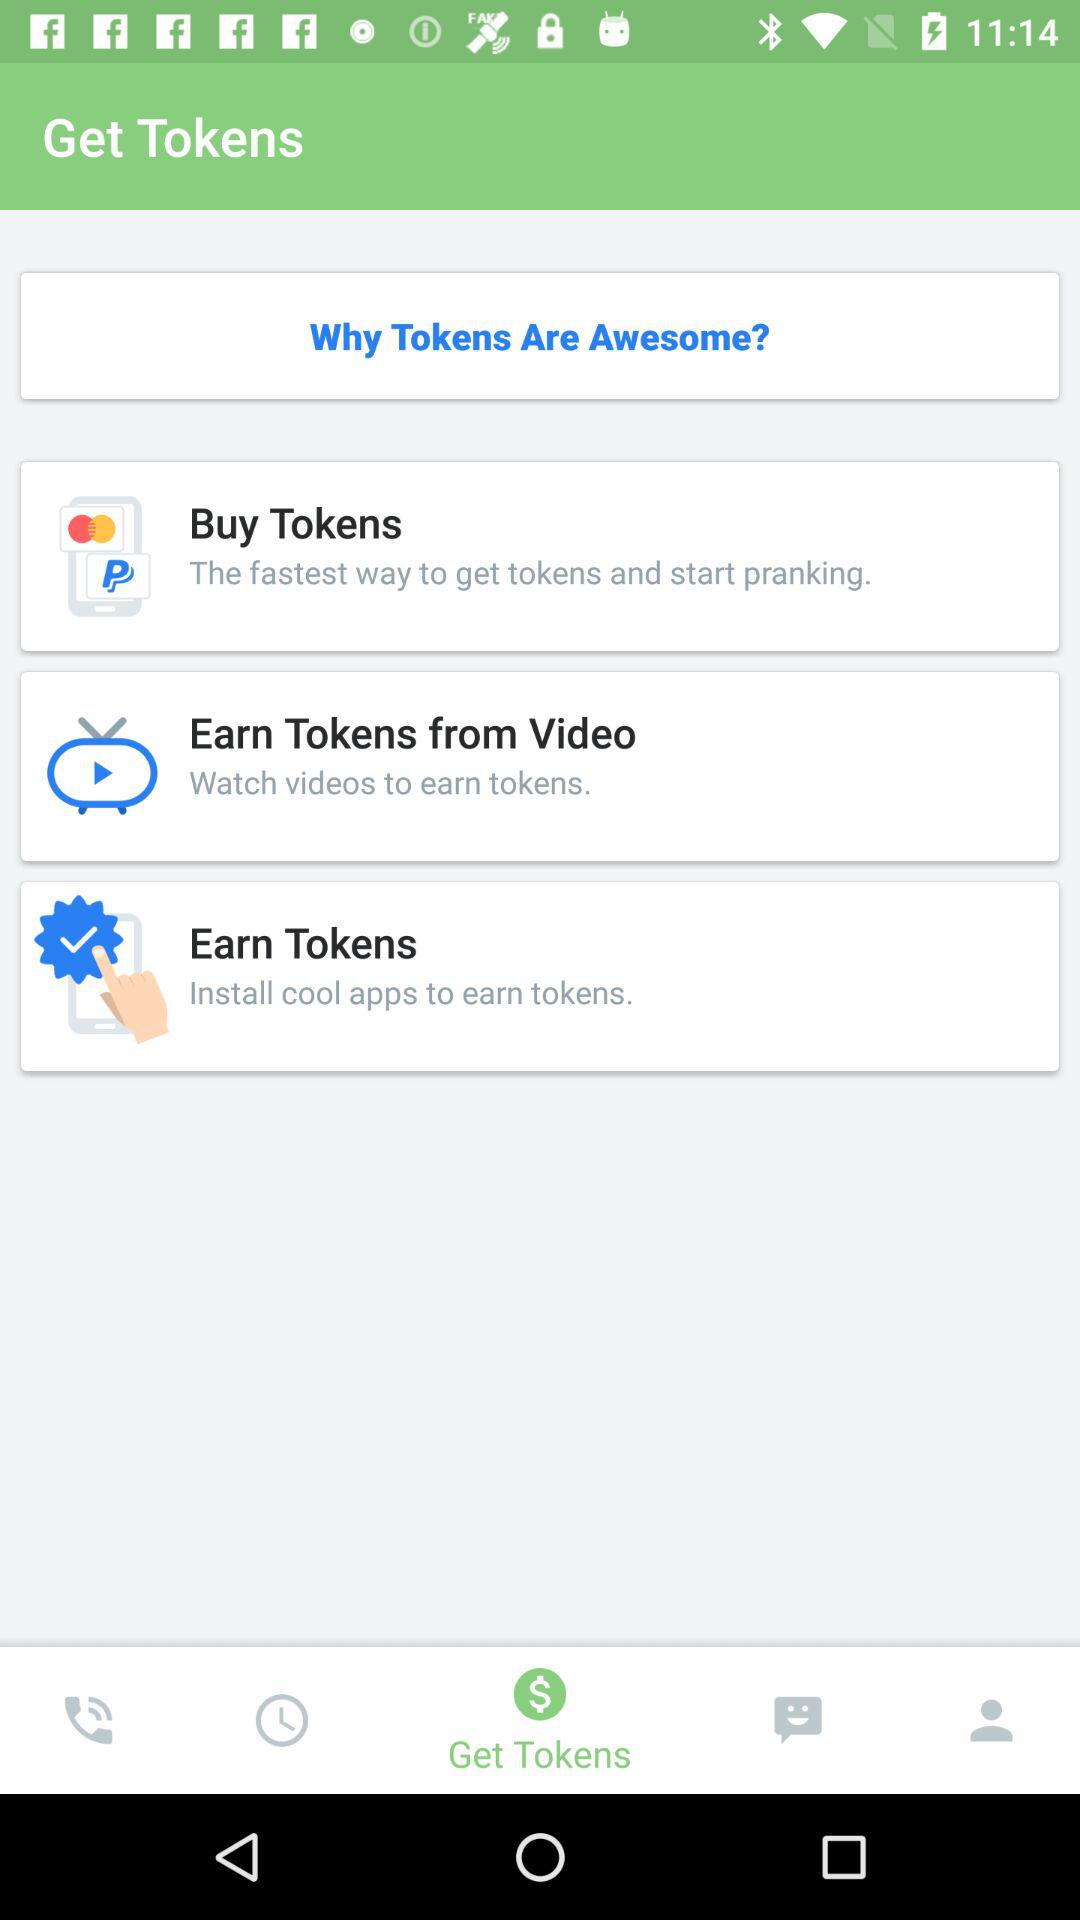What is the selected option? The selected option is "Get Tokens". 